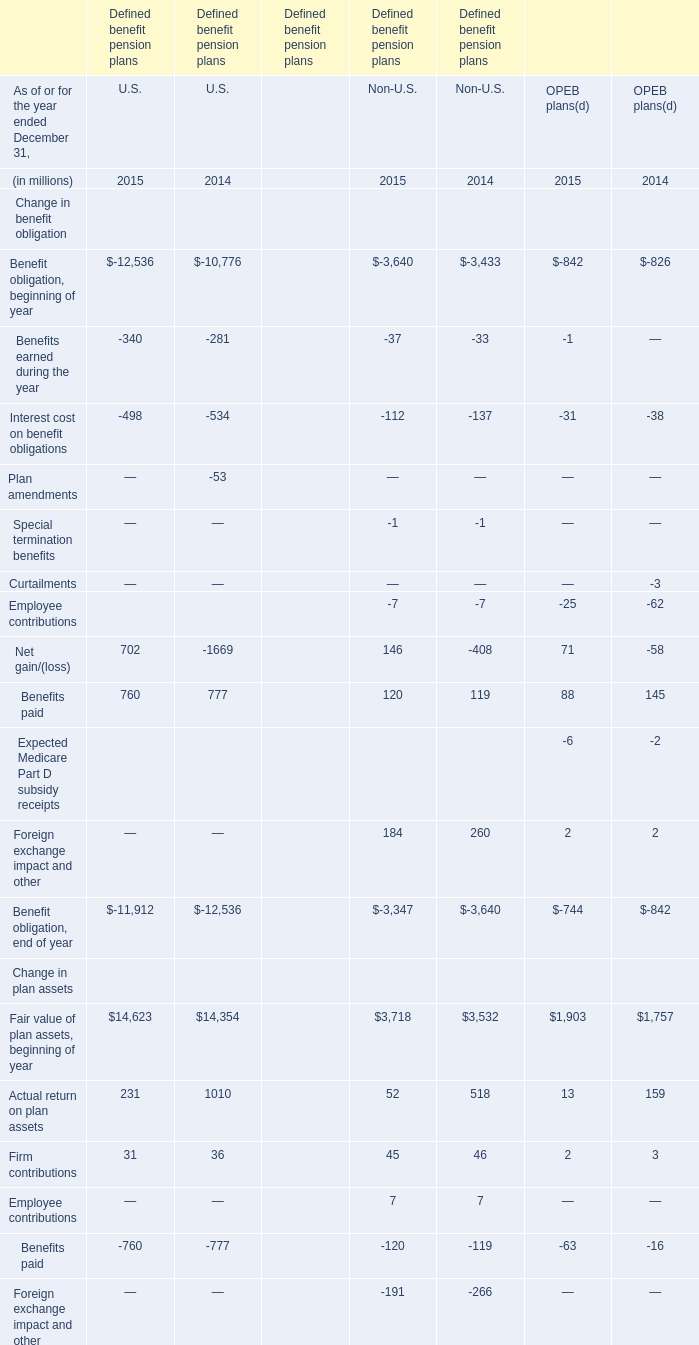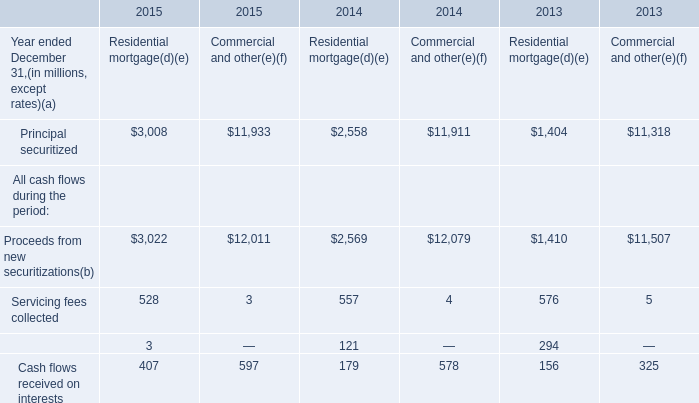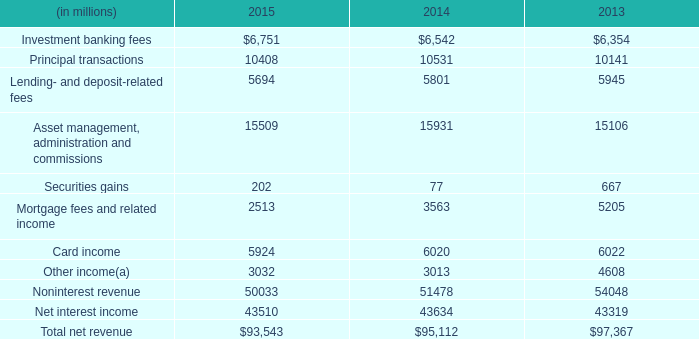When is Fair value of plan assets, end of year in terms of OPEB plans larger? 
Answer: 2014. 